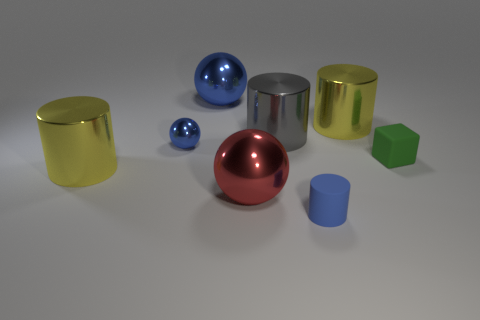Is the material of the green block the same as the big blue ball?
Keep it short and to the point. No. There is a big metallic thing that is the same color as the tiny cylinder; what is its shape?
Provide a succinct answer. Sphere. Do the tiny thing to the right of the small blue rubber cylinder and the small cylinder have the same color?
Offer a very short reply. No. There is a yellow shiny cylinder to the right of the small blue cylinder; what number of metallic things are to the right of it?
Your response must be concise. 0. There is a metallic thing that is the same size as the green rubber cube; what color is it?
Your answer should be very brief. Blue. What is the big cylinder in front of the large gray metal thing made of?
Provide a succinct answer. Metal. There is a tiny thing that is on the left side of the green matte thing and to the right of the red shiny ball; what is its material?
Ensure brevity in your answer.  Rubber. Is the size of the yellow object that is behind the green block the same as the tiny cube?
Make the answer very short. No. The green rubber thing has what shape?
Make the answer very short. Cube. How many other matte objects have the same shape as the green matte thing?
Provide a short and direct response. 0. 